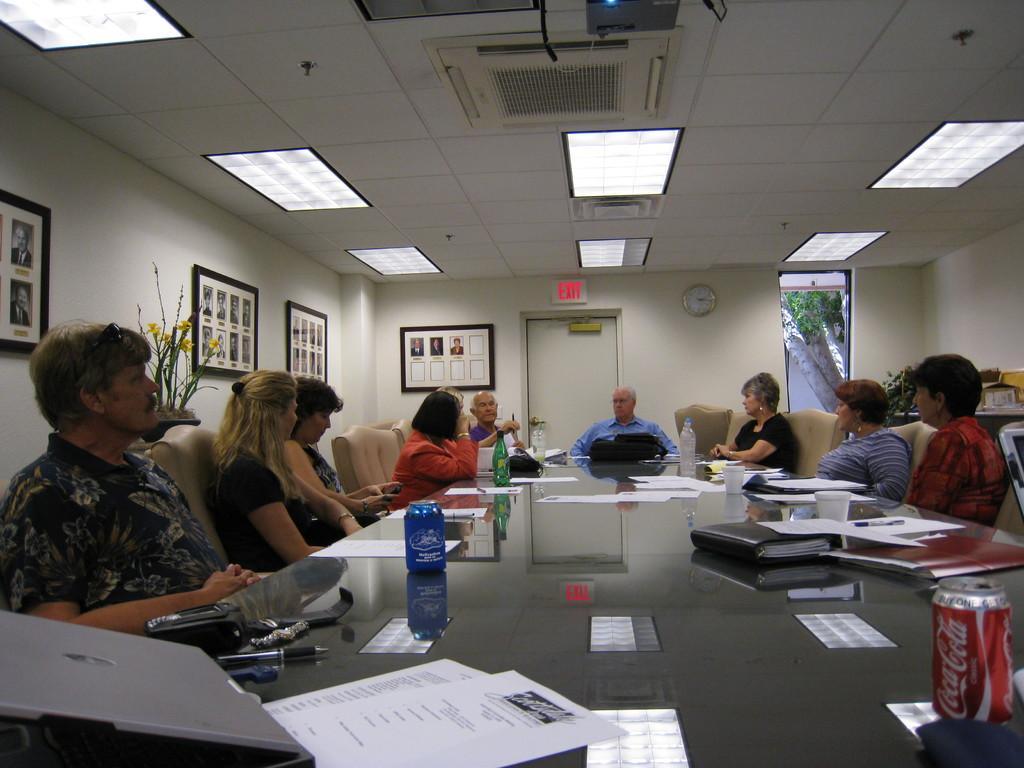Describe this image in one or two sentences. As we can see in the image, there are group of people sitting on chairs and there is a table over here. On table there are papers, books, glasses and there is a white color wall. On wall there is a clock and four photo frames. 